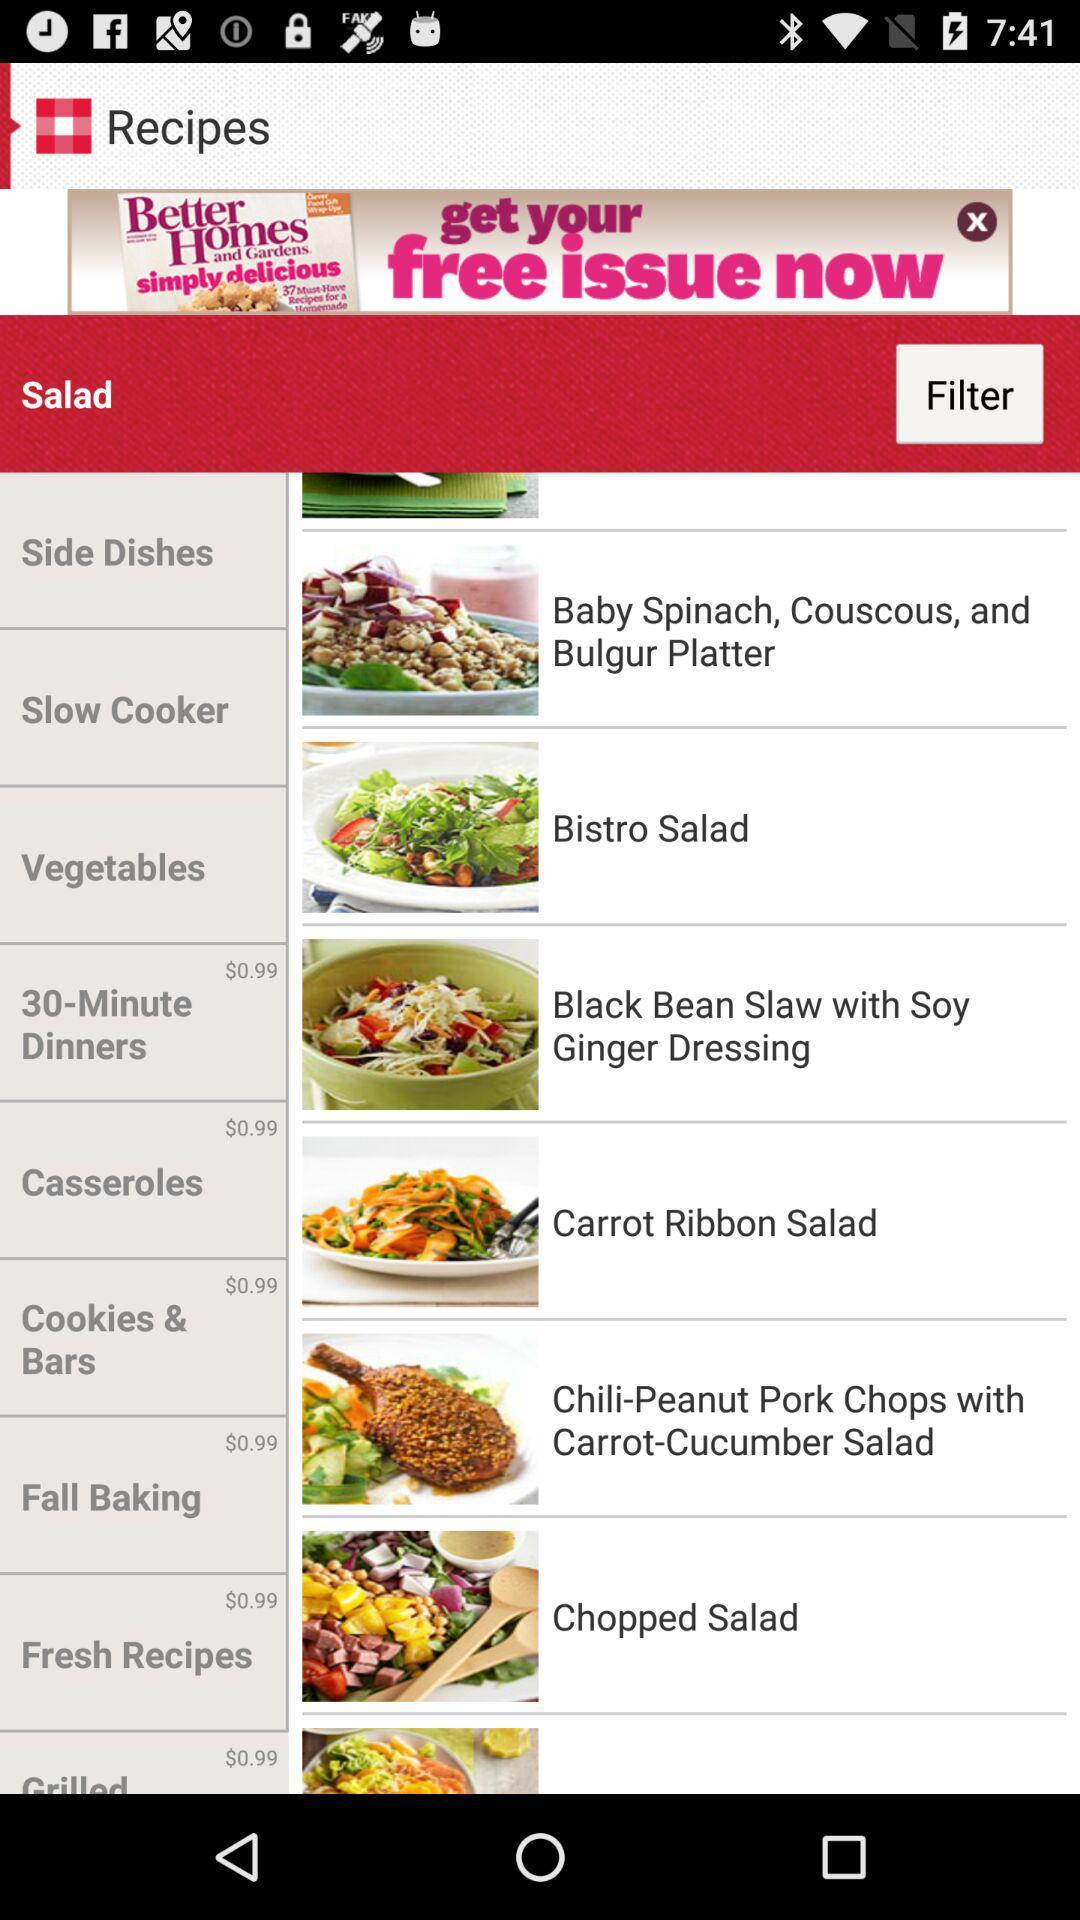What is the price of "Fall Baking"? The price is $0.99. 